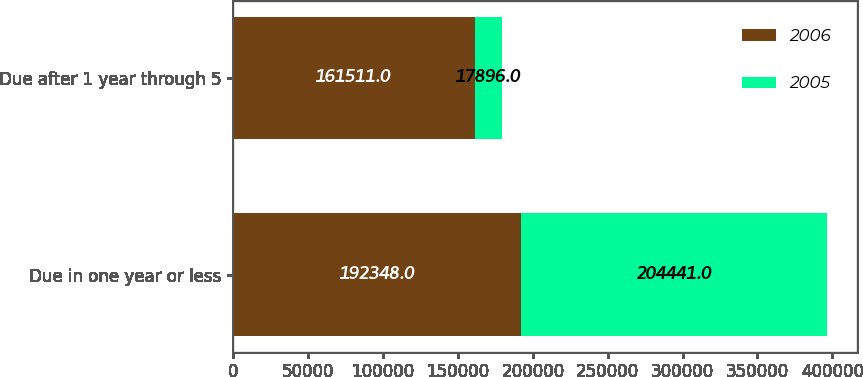Convert chart. <chart><loc_0><loc_0><loc_500><loc_500><stacked_bar_chart><ecel><fcel>Due in one year or less<fcel>Due after 1 year through 5<nl><fcel>2006<fcel>192348<fcel>161511<nl><fcel>2005<fcel>204441<fcel>17896<nl></chart> 